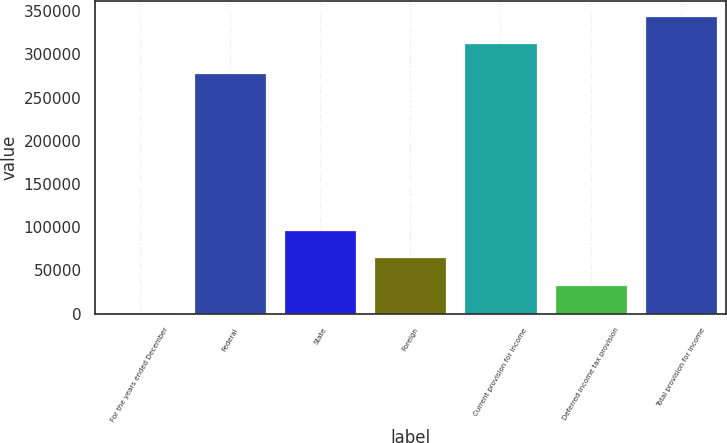Convert chart to OTSL. <chart><loc_0><loc_0><loc_500><loc_500><bar_chart><fcel>For the years ended December<fcel>Federal<fcel>State<fcel>Foreign<fcel>Current provision for income<fcel>Deferred income tax provision<fcel>Total provision for income<nl><fcel>2006<fcel>279017<fcel>96636.5<fcel>65093<fcel>313268<fcel>33549.5<fcel>344812<nl></chart> 